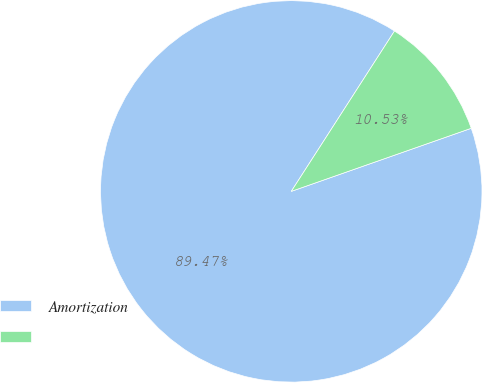Convert chart to OTSL. <chart><loc_0><loc_0><loc_500><loc_500><pie_chart><fcel>Amortization<fcel>Unnamed: 1<nl><fcel>89.47%<fcel>10.53%<nl></chart> 